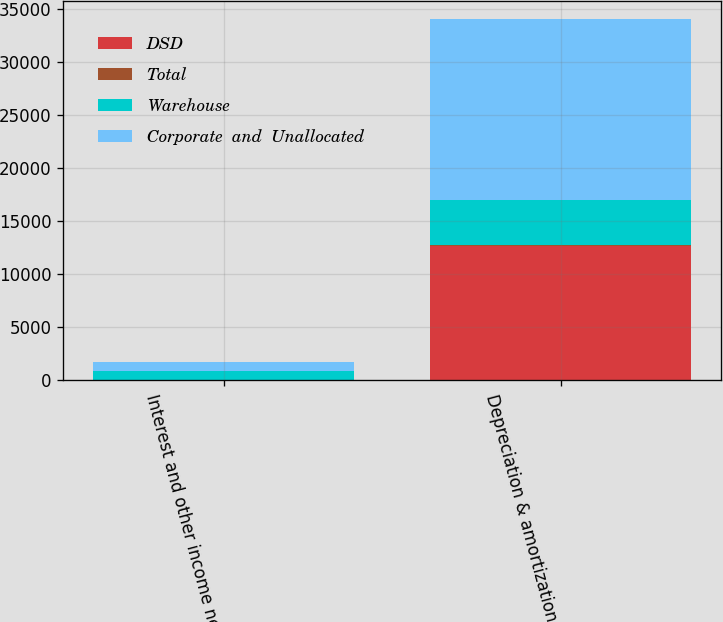Convert chart. <chart><loc_0><loc_0><loc_500><loc_500><stacked_bar_chart><ecel><fcel>Interest and other income net<fcel>Depreciation & amortization<nl><fcel>DSD<fcel>12<fcel>12684<nl><fcel>Total<fcel>1<fcel>87<nl><fcel>Warehouse<fcel>860<fcel>4261<nl><fcel>Corporate  and  Unallocated<fcel>847<fcel>17032<nl></chart> 